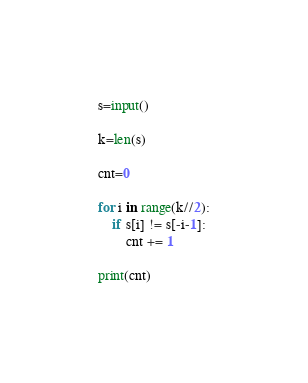Convert code to text. <code><loc_0><loc_0><loc_500><loc_500><_Python_>s=input()

k=len(s)

cnt=0

for i in range(k//2):
    if s[i] != s[-i-1]:
        cnt += 1

print(cnt)</code> 